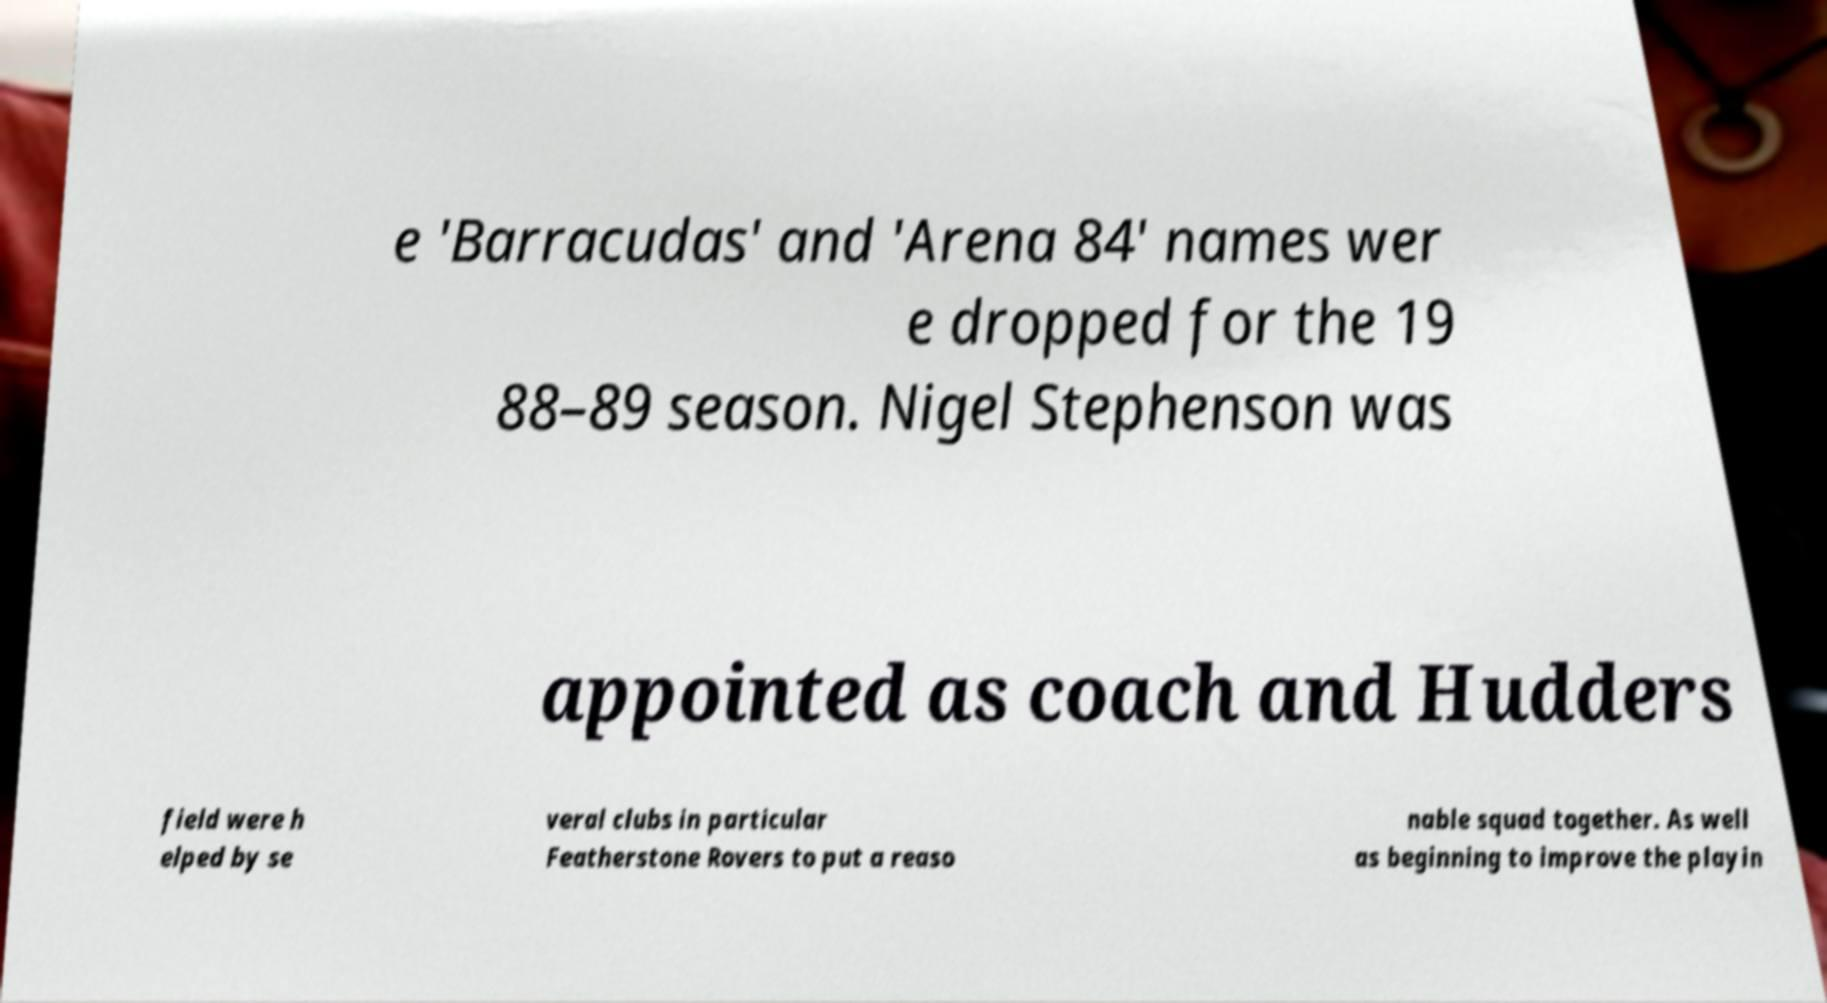There's text embedded in this image that I need extracted. Can you transcribe it verbatim? e 'Barracudas' and 'Arena 84' names wer e dropped for the 19 88–89 season. Nigel Stephenson was appointed as coach and Hudders field were h elped by se veral clubs in particular Featherstone Rovers to put a reaso nable squad together. As well as beginning to improve the playin 